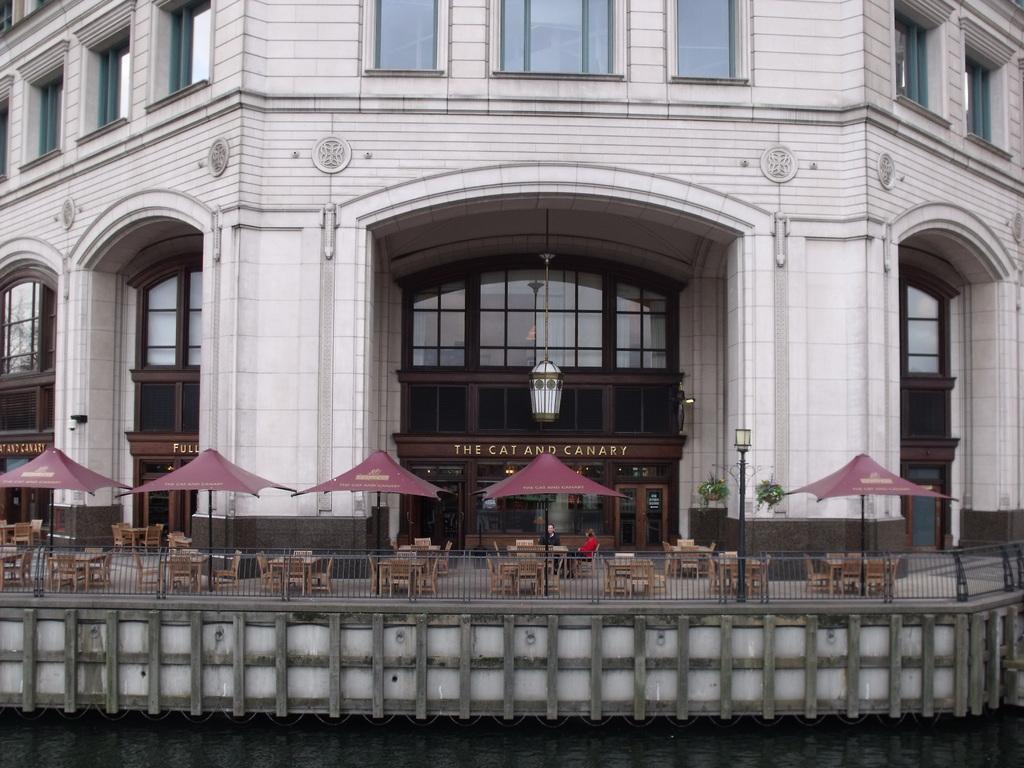Describe this image in one or two sentences. In this picture there is a building. In front of the doors I can see many tables, chairs and umbrellas. In the center I can see the light which is hanging on the from this roof. At the bottom I can see the woman and man who are sitting on the chair near to the table. Beside the umbrellas I can see the fencing. 